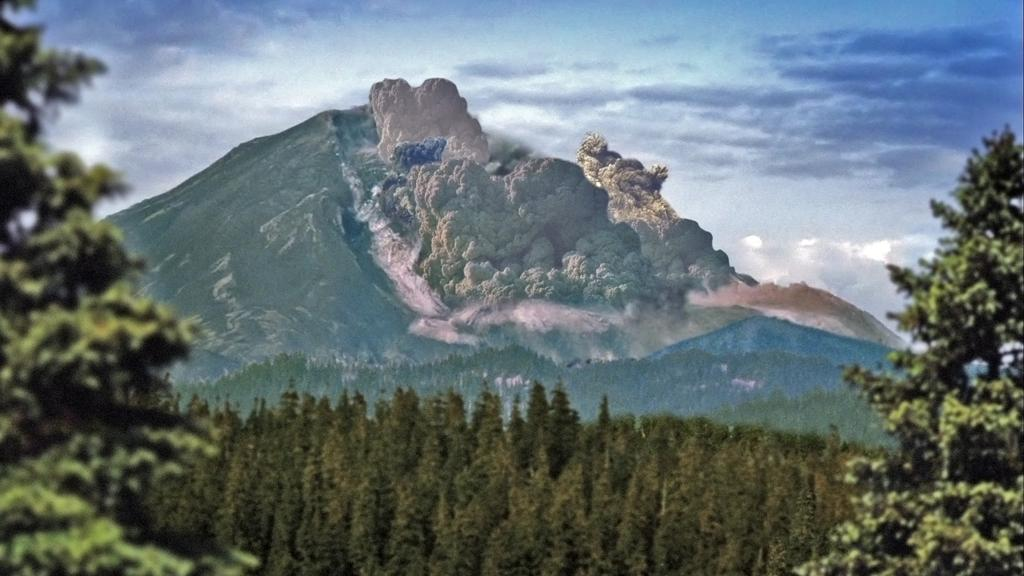What type of vegetation can be seen in the image? There are trees in the image. What geographical feature is present in the image? There is a hill in the image. What is visible in the background of the image? The sky is visible in the background of the image. What can be observed in the sky? Clouds are present in the sky. Can you tell me how many crows are sitting on the hill in the image? There are no crows present in the image; it features trees and a hill. What type of approval is being given in the image? There is no approval process depicted in the image; it shows trees, a hill, and the sky. 